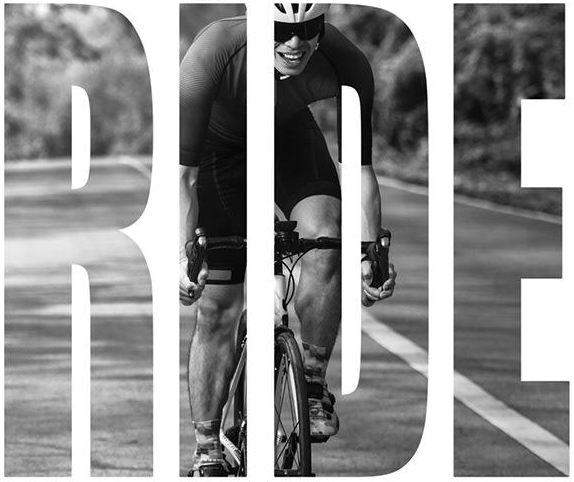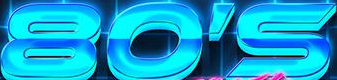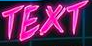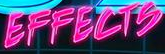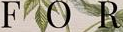Transcribe the words shown in these images in order, separated by a semicolon. RIDE; 80'S; TEXT; EFFECTS; FOR 